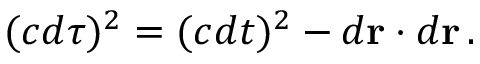<formula> <loc_0><loc_0><loc_500><loc_500>( c d \tau ) ^ { 2 } = ( c d t ) ^ { 2 } - d r \cdot d r \, .</formula> 